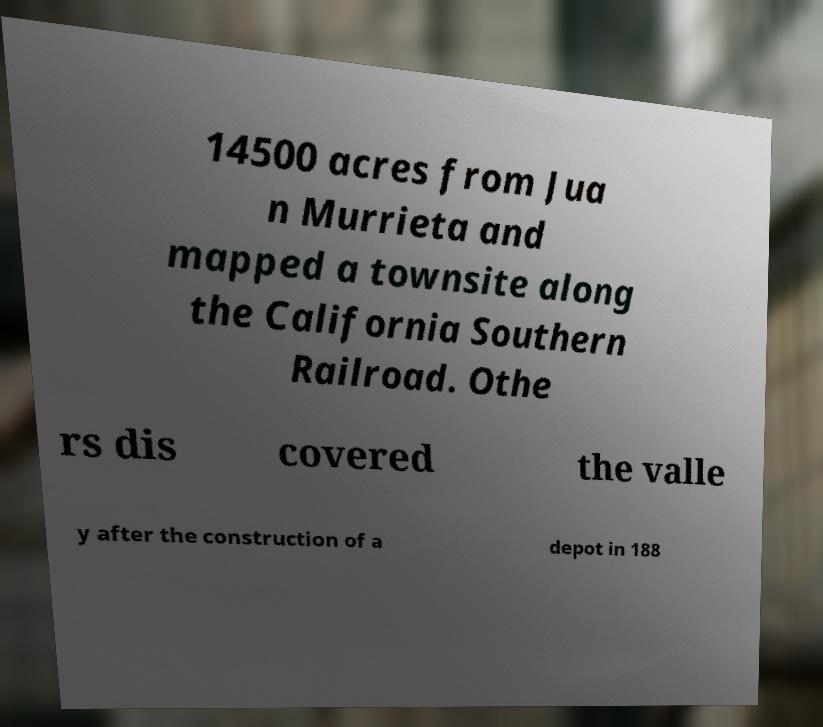Can you accurately transcribe the text from the provided image for me? 14500 acres from Jua n Murrieta and mapped a townsite along the California Southern Railroad. Othe rs dis covered the valle y after the construction of a depot in 188 